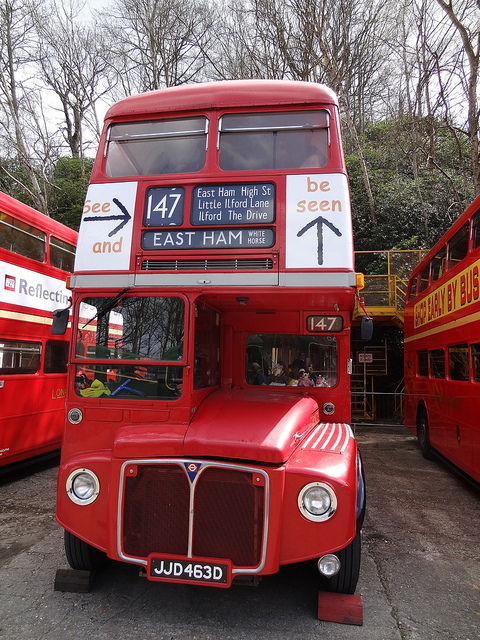Please transcribe the text in this image. 147 EAST HAM and seen EARLY BY BUS JJD 463D Drive The Lford Littel IL Ford Lane St High Ham East HOUSE WHITE See be 147 Reflectin 